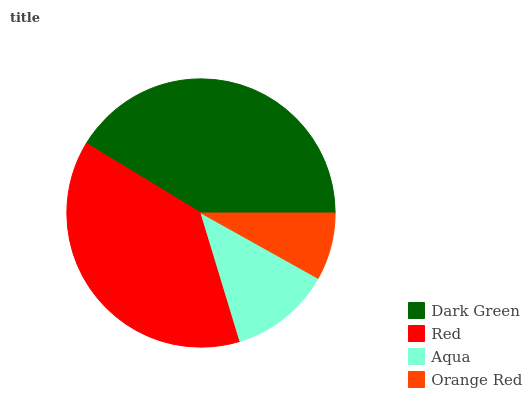Is Orange Red the minimum?
Answer yes or no. Yes. Is Dark Green the maximum?
Answer yes or no. Yes. Is Red the minimum?
Answer yes or no. No. Is Red the maximum?
Answer yes or no. No. Is Dark Green greater than Red?
Answer yes or no. Yes. Is Red less than Dark Green?
Answer yes or no. Yes. Is Red greater than Dark Green?
Answer yes or no. No. Is Dark Green less than Red?
Answer yes or no. No. Is Red the high median?
Answer yes or no. Yes. Is Aqua the low median?
Answer yes or no. Yes. Is Dark Green the high median?
Answer yes or no. No. Is Red the low median?
Answer yes or no. No. 